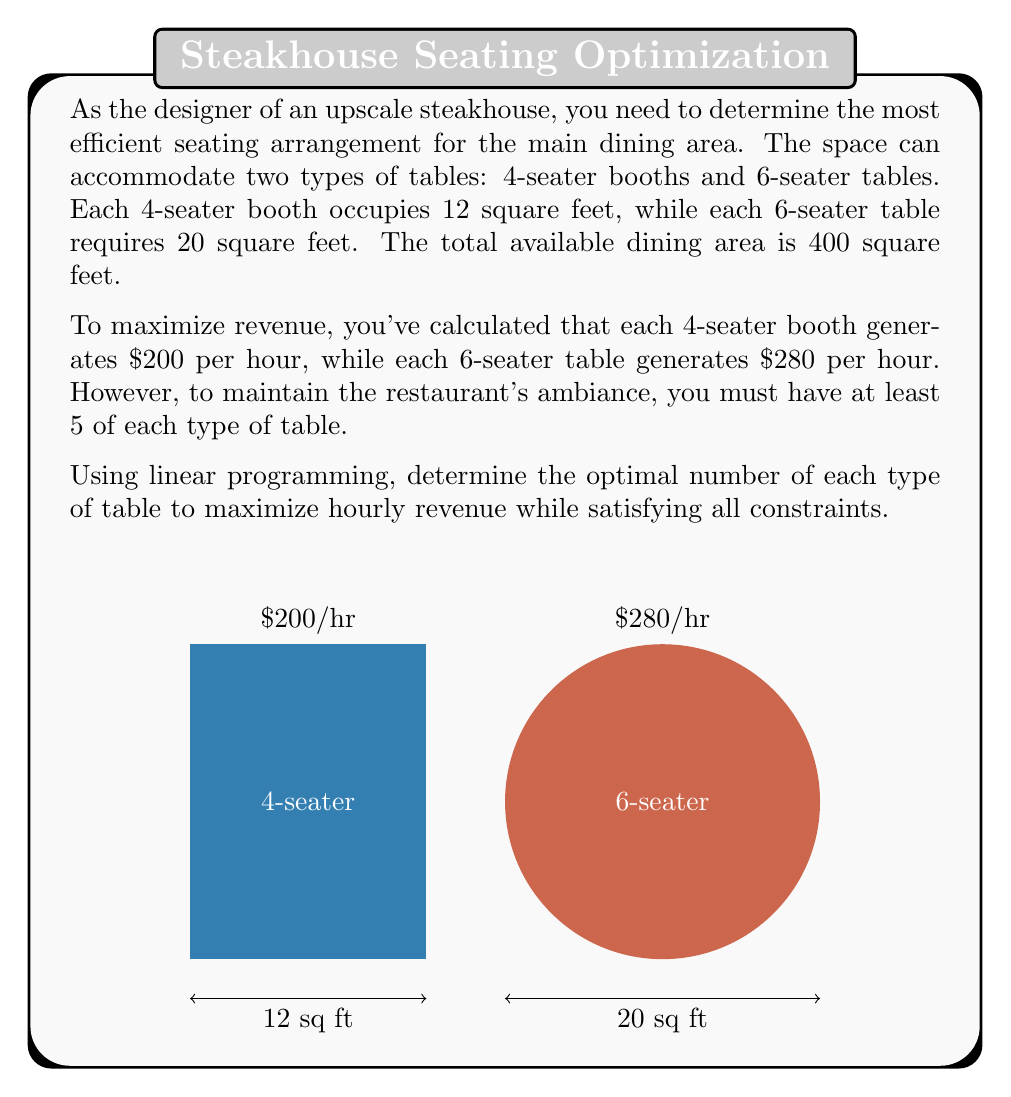Can you answer this question? Let's solve this problem using linear programming:

1) Define variables:
   Let $x$ = number of 4-seater booths
   Let $y$ = number of 6-seater tables

2) Objective function (to maximize hourly revenue):
   $$\text{Maximize } Z = 200x + 280y$$

3) Constraints:
   a) Space constraint: $12x + 20y \leq 400$
   b) Minimum number of each type: $x \geq 5$ and $y \geq 5$
   c) Non-negativity: $x \geq 0$ and $y \geq 0$ (already satisfied by b)

4) Solve using the graphical method:
   Plot the constraints:
   $12x + 20y = 400$ intersects at (33.33, 0) and (0, 20)
   $x = 5$ is a vertical line
   $y = 5$ is a horizontal line

5) The feasible region is the area bounded by these lines. The optimal solution will be at one of the corner points of this region.

6) Corner points:
   (5, 5), (5, 18.75), (25, 5)

7) Evaluate Z at each point:
   (5, 5):    Z = 200(5) + 280(5) = 2400
   (5, 18.75): Z = 200(5) + 280(18.75) = 6250
   (25, 5):   Z = 200(25) + 280(5) = 6400

8) The maximum value of Z occurs at (25, 5)

Therefore, the optimal solution is 25 4-seater booths and 5 6-seater tables.
Answer: 25 4-seater booths, 5 6-seater tables 